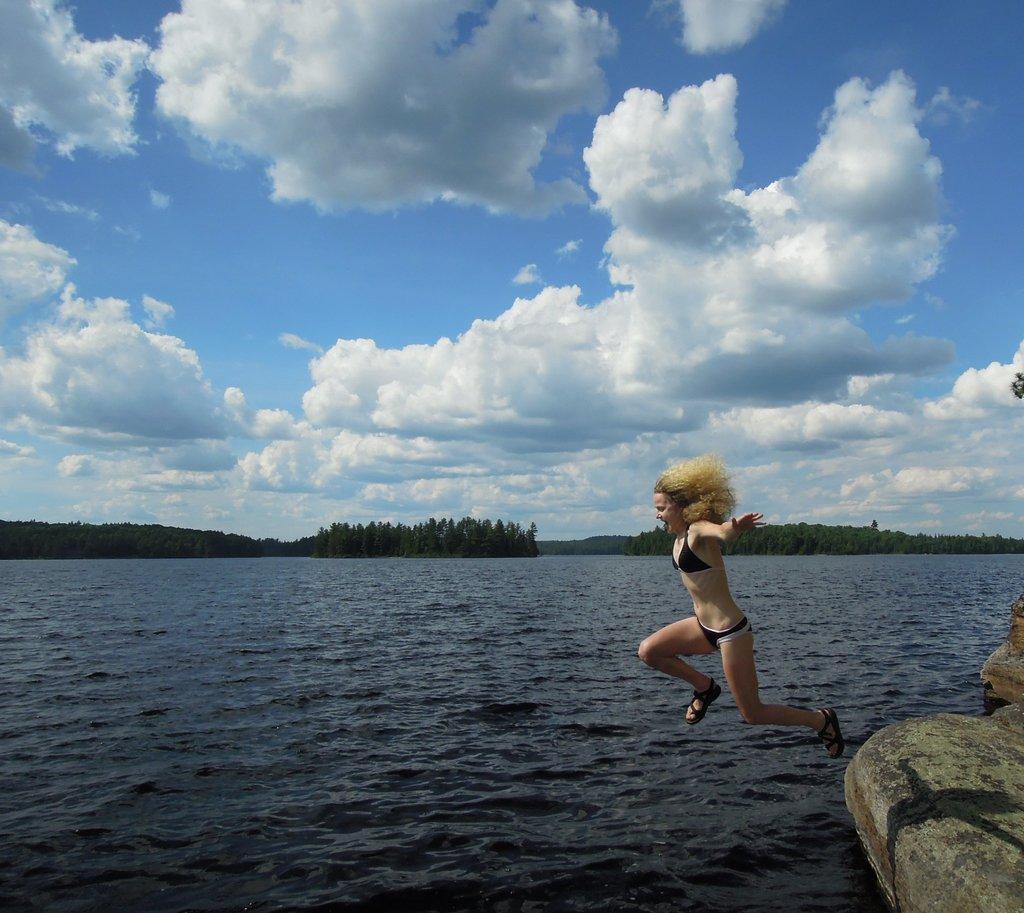Describe this image in one or two sentences. In the foreground of the picture there are stones, water body and a woman jumping into the water. In the middle of the picture there are trees. At the top we can see clouds and sky. 